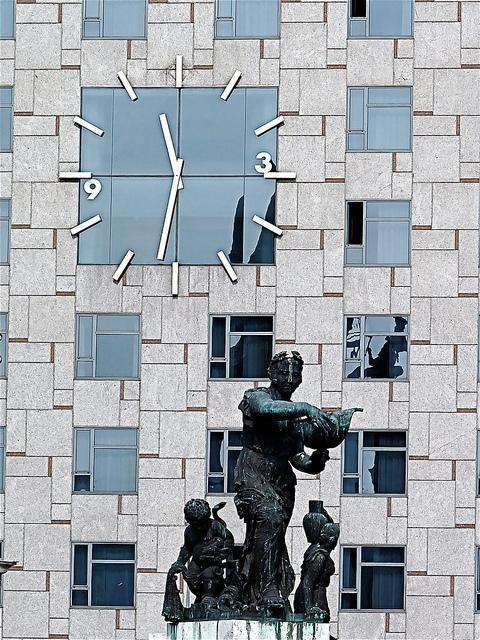How many clock faces are there?
Give a very brief answer. 1. 